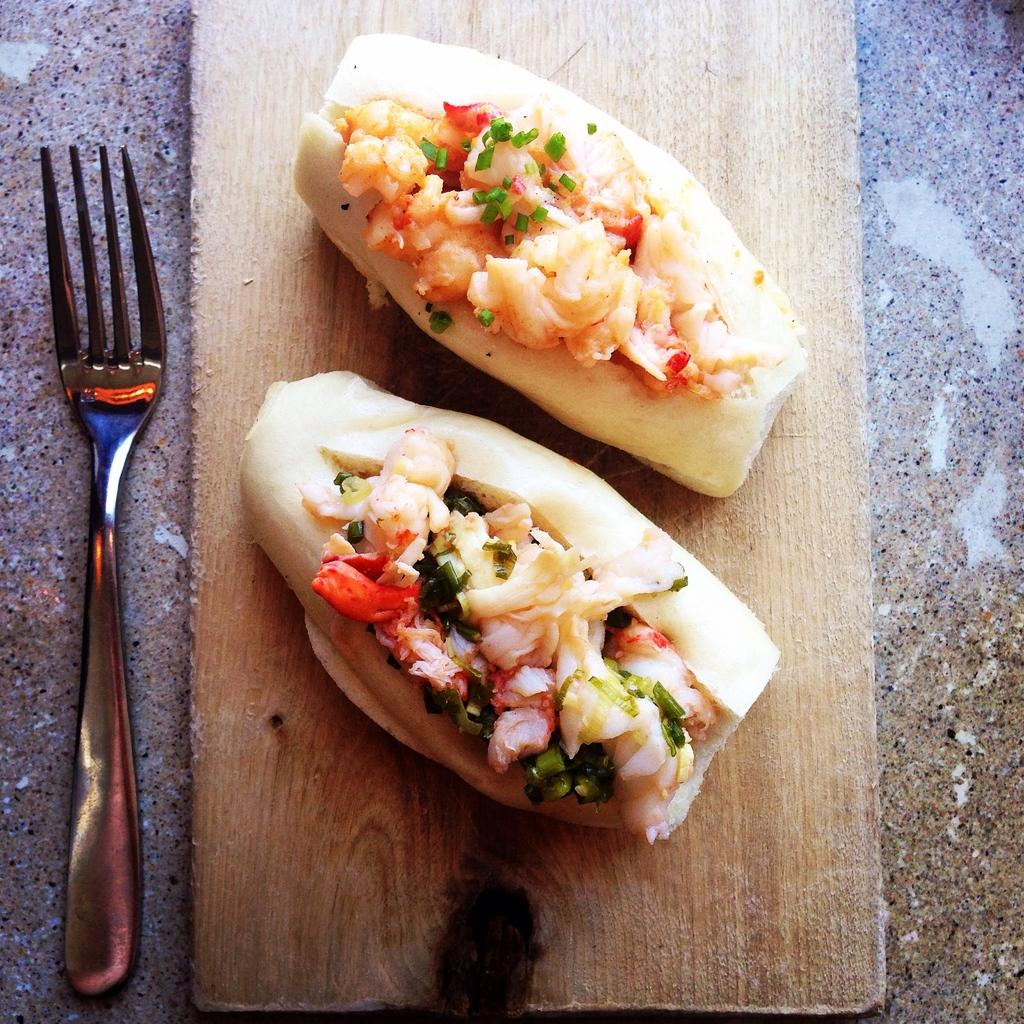What are the two food items on the wooden board? The facts do not specify the exact food items, but there are two food items on the wooden board. What utensil is present on the wooden board? There is a fork on the wooden board. What is the wooden board placed on? The wooden board is on a granite surface. How many roses are on the wooden board? There are no roses present on the wooden board in the image. What type of bead is used to decorate the food items? There is no mention of beads or any decorative elements in the image. 